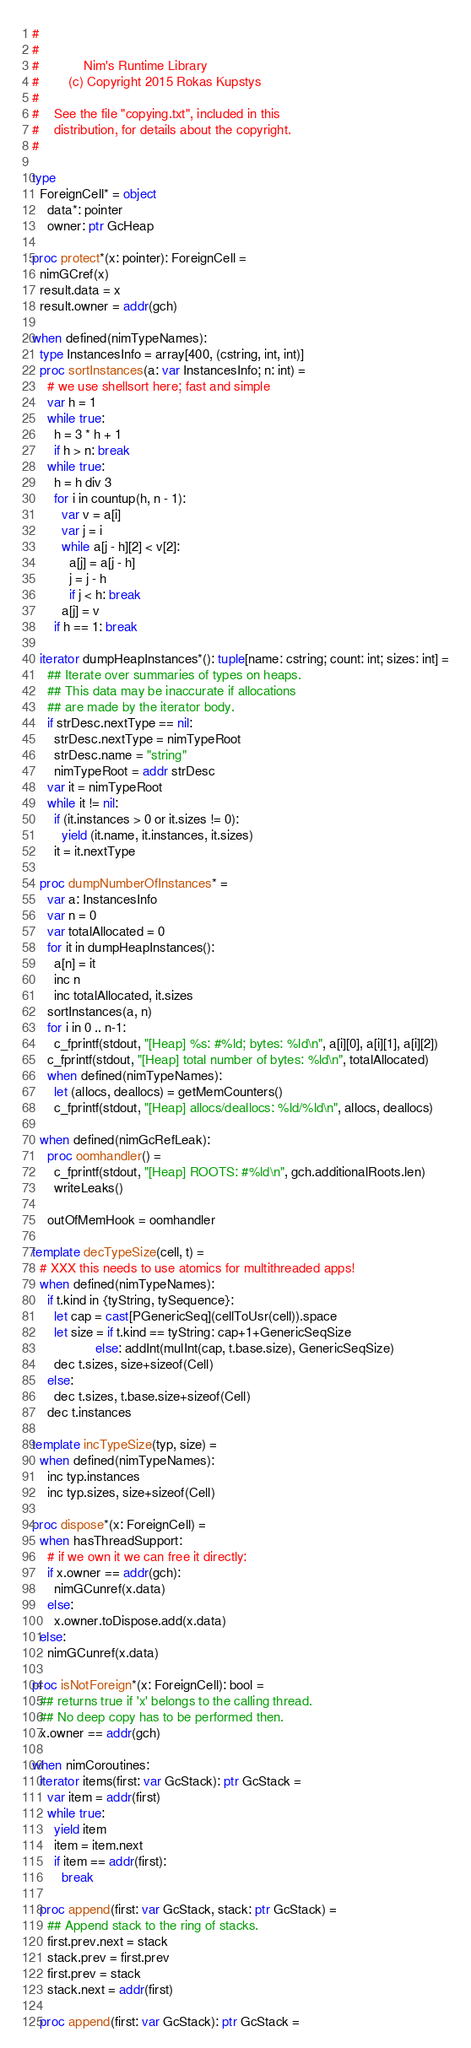<code> <loc_0><loc_0><loc_500><loc_500><_Nim_>#
#
#            Nim's Runtime Library
#        (c) Copyright 2015 Rokas Kupstys
#
#    See the file "copying.txt", included in this
#    distribution, for details about the copyright.
#

type
  ForeignCell* = object
    data*: pointer
    owner: ptr GcHeap

proc protect*(x: pointer): ForeignCell =
  nimGCref(x)
  result.data = x
  result.owner = addr(gch)

when defined(nimTypeNames):
  type InstancesInfo = array[400, (cstring, int, int)]
  proc sortInstances(a: var InstancesInfo; n: int) =
    # we use shellsort here; fast and simple
    var h = 1
    while true:
      h = 3 * h + 1
      if h > n: break
    while true:
      h = h div 3
      for i in countup(h, n - 1):
        var v = a[i]
        var j = i
        while a[j - h][2] < v[2]:
          a[j] = a[j - h]
          j = j - h
          if j < h: break
        a[j] = v
      if h == 1: break

  iterator dumpHeapInstances*(): tuple[name: cstring; count: int; sizes: int] =
    ## Iterate over summaries of types on heaps.
    ## This data may be inaccurate if allocations
    ## are made by the iterator body.
    if strDesc.nextType == nil:
      strDesc.nextType = nimTypeRoot
      strDesc.name = "string"
      nimTypeRoot = addr strDesc
    var it = nimTypeRoot
    while it != nil:
      if (it.instances > 0 or it.sizes != 0):
        yield (it.name, it.instances, it.sizes)
      it = it.nextType

  proc dumpNumberOfInstances* =
    var a: InstancesInfo
    var n = 0
    var totalAllocated = 0
    for it in dumpHeapInstances():
      a[n] = it
      inc n
      inc totalAllocated, it.sizes
    sortInstances(a, n)
    for i in 0 .. n-1:
      c_fprintf(stdout, "[Heap] %s: #%ld; bytes: %ld\n", a[i][0], a[i][1], a[i][2])
    c_fprintf(stdout, "[Heap] total number of bytes: %ld\n", totalAllocated)
    when defined(nimTypeNames):
      let (allocs, deallocs) = getMemCounters()
      c_fprintf(stdout, "[Heap] allocs/deallocs: %ld/%ld\n", allocs, deallocs)

  when defined(nimGcRefLeak):
    proc oomhandler() =
      c_fprintf(stdout, "[Heap] ROOTS: #%ld\n", gch.additionalRoots.len)
      writeLeaks()

    outOfMemHook = oomhandler

template decTypeSize(cell, t) =
  # XXX this needs to use atomics for multithreaded apps!
  when defined(nimTypeNames):
    if t.kind in {tyString, tySequence}:
      let cap = cast[PGenericSeq](cellToUsr(cell)).space
      let size = if t.kind == tyString: cap+1+GenericSeqSize
                 else: addInt(mulInt(cap, t.base.size), GenericSeqSize)
      dec t.sizes, size+sizeof(Cell)
    else:
      dec t.sizes, t.base.size+sizeof(Cell)
    dec t.instances

template incTypeSize(typ, size) =
  when defined(nimTypeNames):
    inc typ.instances
    inc typ.sizes, size+sizeof(Cell)

proc dispose*(x: ForeignCell) =
  when hasThreadSupport:
    # if we own it we can free it directly:
    if x.owner == addr(gch):
      nimGCunref(x.data)
    else:
      x.owner.toDispose.add(x.data)
  else:
    nimGCunref(x.data)

proc isNotForeign*(x: ForeignCell): bool =
  ## returns true if 'x' belongs to the calling thread.
  ## No deep copy has to be performed then.
  x.owner == addr(gch)

when nimCoroutines:
  iterator items(first: var GcStack): ptr GcStack =
    var item = addr(first)
    while true:
      yield item
      item = item.next
      if item == addr(first):
        break

  proc append(first: var GcStack, stack: ptr GcStack) =
    ## Append stack to the ring of stacks.
    first.prev.next = stack
    stack.prev = first.prev
    first.prev = stack
    stack.next = addr(first)

  proc append(first: var GcStack): ptr GcStack =</code> 